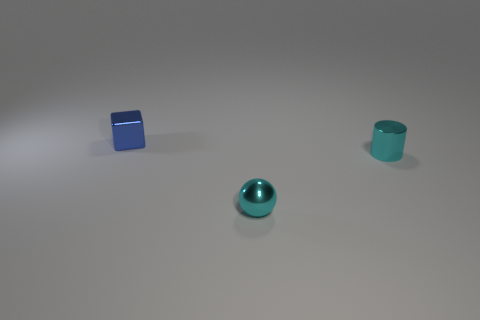The tiny shiny thing that is the same color as the cylinder is what shape?
Your answer should be very brief. Sphere. What number of objects are cyan things to the left of the small cyan cylinder or green things?
Your answer should be very brief. 1. What color is the metal object left of the cyan metallic ball?
Your answer should be compact. Blue. Is the size of the cylinder the same as the object that is behind the cyan cylinder?
Offer a very short reply. Yes. There is a cyan thing to the left of the metallic cylinder; what material is it?
Provide a short and direct response. Metal. How many blue things are on the right side of the tiny metal object behind the small cyan metallic cylinder?
Provide a short and direct response. 0. Is the size of the cylinder that is on the right side of the cyan ball the same as the cyan thing that is on the left side of the tiny metallic cylinder?
Keep it short and to the point. Yes. What shape is the tiny thing that is behind the tiny cyan thing behind the small metallic sphere?
Offer a very short reply. Cube. How many other shiny cylinders have the same size as the shiny cylinder?
Your answer should be very brief. 0. Is there a matte ball?
Your answer should be very brief. No. 